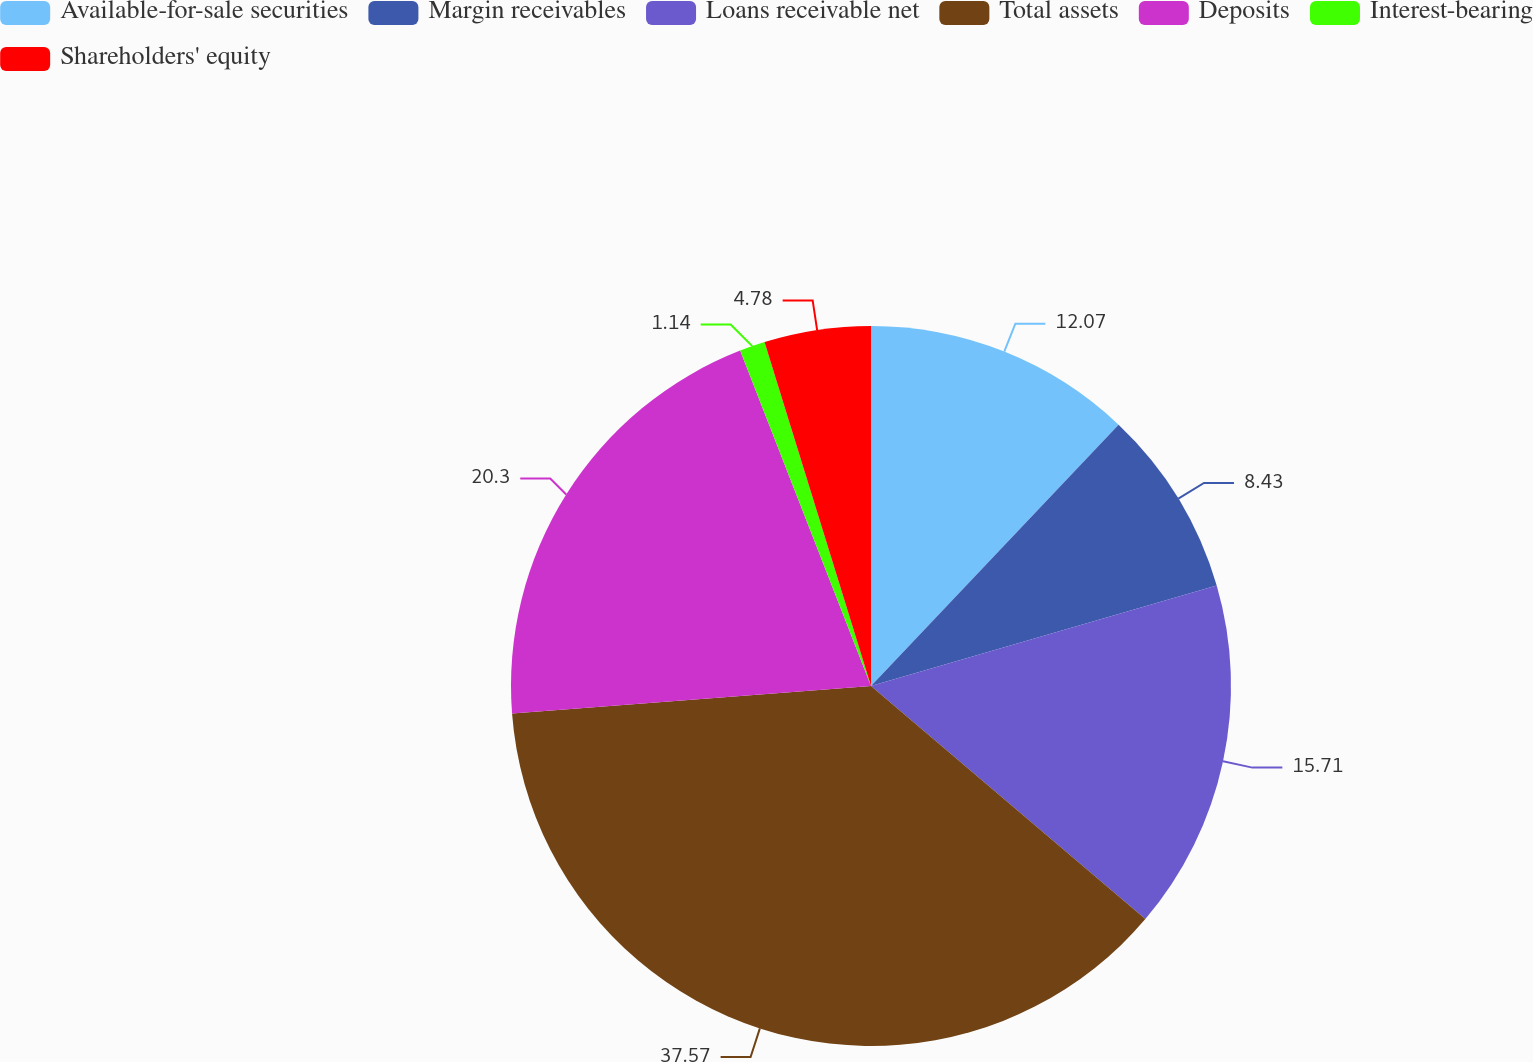Convert chart. <chart><loc_0><loc_0><loc_500><loc_500><pie_chart><fcel>Available-for-sale securities<fcel>Margin receivables<fcel>Loans receivable net<fcel>Total assets<fcel>Deposits<fcel>Interest-bearing<fcel>Shareholders' equity<nl><fcel>12.07%<fcel>8.43%<fcel>15.71%<fcel>37.57%<fcel>20.3%<fcel>1.14%<fcel>4.78%<nl></chart> 